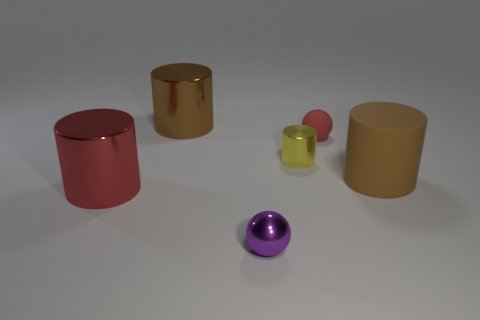Subtract all rubber cylinders. How many cylinders are left? 3 Subtract all cylinders. How many objects are left? 2 Subtract all brown cylinders. How many cylinders are left? 2 Subtract 0 gray cubes. How many objects are left? 6 Subtract 3 cylinders. How many cylinders are left? 1 Subtract all purple balls. Subtract all cyan cylinders. How many balls are left? 1 Subtract all red balls. How many blue cylinders are left? 0 Subtract all large rubber things. Subtract all large brown rubber cylinders. How many objects are left? 4 Add 1 large matte cylinders. How many large matte cylinders are left? 2 Add 1 big brown shiny objects. How many big brown shiny objects exist? 2 